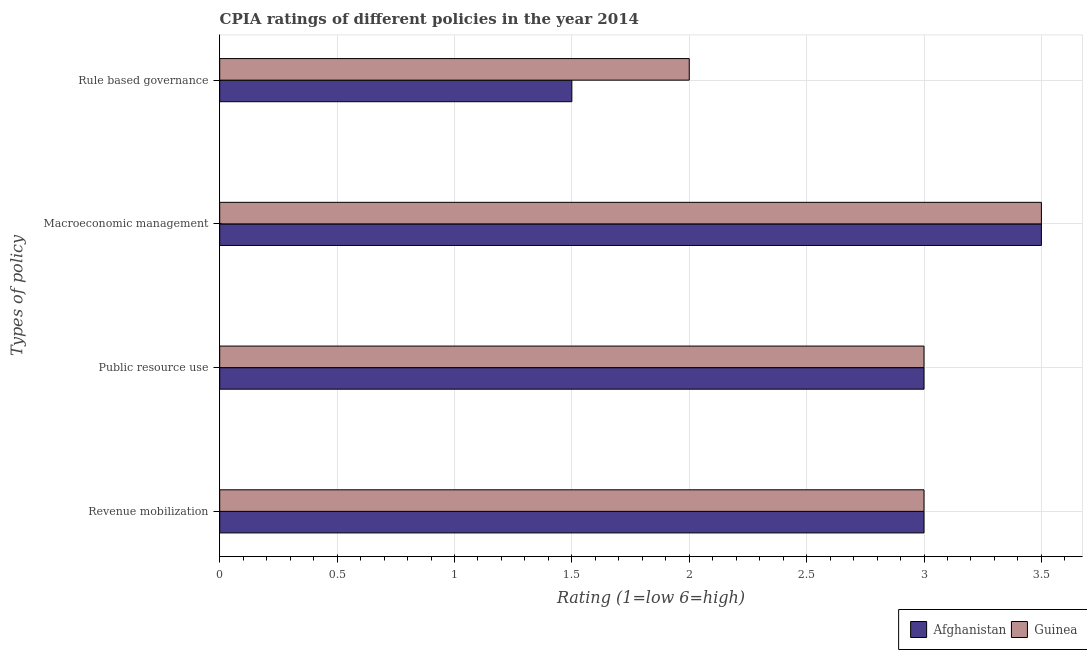How many groups of bars are there?
Your answer should be very brief. 4. How many bars are there on the 2nd tick from the top?
Ensure brevity in your answer.  2. What is the label of the 1st group of bars from the top?
Provide a short and direct response. Rule based governance. Across all countries, what is the minimum cpia rating of rule based governance?
Give a very brief answer. 1.5. In which country was the cpia rating of rule based governance maximum?
Your answer should be compact. Guinea. In which country was the cpia rating of revenue mobilization minimum?
Your answer should be very brief. Afghanistan. What is the difference between the cpia rating of rule based governance and cpia rating of macroeconomic management in Afghanistan?
Your response must be concise. -2. What is the ratio of the cpia rating of rule based governance in Afghanistan to that in Guinea?
Your answer should be very brief. 0.75. Is the cpia rating of macroeconomic management in Afghanistan less than that in Guinea?
Your response must be concise. No. What is the difference between the highest and the second highest cpia rating of rule based governance?
Ensure brevity in your answer.  0.5. What is the difference between the highest and the lowest cpia rating of macroeconomic management?
Give a very brief answer. 0. In how many countries, is the cpia rating of macroeconomic management greater than the average cpia rating of macroeconomic management taken over all countries?
Your response must be concise. 0. Is the sum of the cpia rating of macroeconomic management in Guinea and Afghanistan greater than the maximum cpia rating of revenue mobilization across all countries?
Provide a short and direct response. Yes. What does the 2nd bar from the top in Macroeconomic management represents?
Provide a short and direct response. Afghanistan. What does the 2nd bar from the bottom in Public resource use represents?
Keep it short and to the point. Guinea. What is the difference between two consecutive major ticks on the X-axis?
Provide a succinct answer. 0.5. How many legend labels are there?
Offer a terse response. 2. What is the title of the graph?
Offer a terse response. CPIA ratings of different policies in the year 2014. What is the label or title of the Y-axis?
Offer a terse response. Types of policy. What is the Rating (1=low 6=high) of Afghanistan in Revenue mobilization?
Your answer should be compact. 3. What is the Rating (1=low 6=high) in Afghanistan in Public resource use?
Provide a succinct answer. 3. What is the Rating (1=low 6=high) in Guinea in Public resource use?
Ensure brevity in your answer.  3. What is the Rating (1=low 6=high) of Afghanistan in Macroeconomic management?
Provide a succinct answer. 3.5. What is the Rating (1=low 6=high) of Afghanistan in Rule based governance?
Offer a terse response. 1.5. Across all Types of policy, what is the maximum Rating (1=low 6=high) of Afghanistan?
Offer a terse response. 3.5. What is the total Rating (1=low 6=high) of Afghanistan in the graph?
Keep it short and to the point. 11. What is the total Rating (1=low 6=high) in Guinea in the graph?
Your answer should be very brief. 11.5. What is the difference between the Rating (1=low 6=high) of Afghanistan in Revenue mobilization and that in Public resource use?
Offer a terse response. 0. What is the difference between the Rating (1=low 6=high) of Guinea in Revenue mobilization and that in Rule based governance?
Your answer should be compact. 1. What is the difference between the Rating (1=low 6=high) in Afghanistan in Public resource use and that in Macroeconomic management?
Ensure brevity in your answer.  -0.5. What is the difference between the Rating (1=low 6=high) in Afghanistan in Public resource use and that in Rule based governance?
Your answer should be very brief. 1.5. What is the difference between the Rating (1=low 6=high) of Guinea in Public resource use and that in Rule based governance?
Keep it short and to the point. 1. What is the difference between the Rating (1=low 6=high) of Guinea in Macroeconomic management and that in Rule based governance?
Ensure brevity in your answer.  1.5. What is the difference between the Rating (1=low 6=high) in Afghanistan in Revenue mobilization and the Rating (1=low 6=high) in Guinea in Macroeconomic management?
Keep it short and to the point. -0.5. What is the average Rating (1=low 6=high) of Afghanistan per Types of policy?
Keep it short and to the point. 2.75. What is the average Rating (1=low 6=high) of Guinea per Types of policy?
Give a very brief answer. 2.88. What is the ratio of the Rating (1=low 6=high) in Afghanistan in Revenue mobilization to that in Public resource use?
Your answer should be compact. 1. What is the ratio of the Rating (1=low 6=high) in Guinea in Revenue mobilization to that in Macroeconomic management?
Make the answer very short. 0.86. What is the ratio of the Rating (1=low 6=high) of Guinea in Revenue mobilization to that in Rule based governance?
Your answer should be compact. 1.5. What is the ratio of the Rating (1=low 6=high) of Afghanistan in Public resource use to that in Macroeconomic management?
Offer a very short reply. 0.86. What is the ratio of the Rating (1=low 6=high) in Guinea in Public resource use to that in Macroeconomic management?
Offer a terse response. 0.86. What is the ratio of the Rating (1=low 6=high) in Afghanistan in Public resource use to that in Rule based governance?
Give a very brief answer. 2. What is the ratio of the Rating (1=low 6=high) in Guinea in Public resource use to that in Rule based governance?
Offer a very short reply. 1.5. What is the ratio of the Rating (1=low 6=high) in Afghanistan in Macroeconomic management to that in Rule based governance?
Ensure brevity in your answer.  2.33. What is the difference between the highest and the second highest Rating (1=low 6=high) in Afghanistan?
Your answer should be compact. 0.5. What is the difference between the highest and the second highest Rating (1=low 6=high) of Guinea?
Make the answer very short. 0.5. What is the difference between the highest and the lowest Rating (1=low 6=high) in Afghanistan?
Offer a very short reply. 2. 